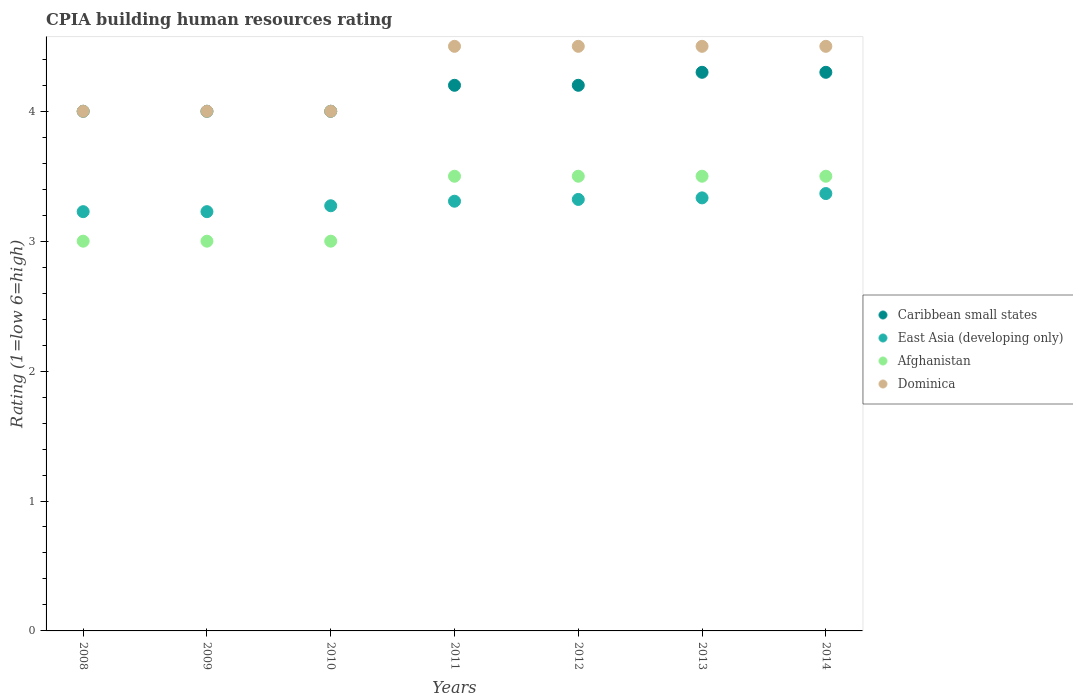Is the number of dotlines equal to the number of legend labels?
Provide a succinct answer. Yes. What is the CPIA rating in Caribbean small states in 2011?
Provide a short and direct response. 4.2. Across all years, what is the maximum CPIA rating in Dominica?
Ensure brevity in your answer.  4.5. Across all years, what is the minimum CPIA rating in Caribbean small states?
Provide a succinct answer. 4. In which year was the CPIA rating in Caribbean small states maximum?
Offer a very short reply. 2013. What is the difference between the CPIA rating in Caribbean small states in 2010 and that in 2012?
Make the answer very short. -0.2. What is the difference between the CPIA rating in Afghanistan in 2010 and the CPIA rating in Dominica in 2009?
Give a very brief answer. -1. What is the average CPIA rating in Caribbean small states per year?
Ensure brevity in your answer.  4.14. In the year 2010, what is the difference between the CPIA rating in Caribbean small states and CPIA rating in East Asia (developing only)?
Your answer should be compact. 0.73. In how many years, is the CPIA rating in Afghanistan greater than 1.8?
Offer a very short reply. 7. What is the ratio of the CPIA rating in East Asia (developing only) in 2008 to that in 2011?
Your answer should be compact. 0.98. Is the CPIA rating in Caribbean small states in 2012 less than that in 2013?
Ensure brevity in your answer.  Yes. Is the difference between the CPIA rating in Caribbean small states in 2010 and 2012 greater than the difference between the CPIA rating in East Asia (developing only) in 2010 and 2012?
Your answer should be compact. No. What is the difference between the highest and the lowest CPIA rating in Caribbean small states?
Provide a short and direct response. 0.3. In how many years, is the CPIA rating in Dominica greater than the average CPIA rating in Dominica taken over all years?
Offer a very short reply. 4. Is the sum of the CPIA rating in Caribbean small states in 2009 and 2010 greater than the maximum CPIA rating in Afghanistan across all years?
Your response must be concise. Yes. Is it the case that in every year, the sum of the CPIA rating in Caribbean small states and CPIA rating in Dominica  is greater than the sum of CPIA rating in Afghanistan and CPIA rating in East Asia (developing only)?
Your answer should be very brief. Yes. Is it the case that in every year, the sum of the CPIA rating in Dominica and CPIA rating in East Asia (developing only)  is greater than the CPIA rating in Caribbean small states?
Give a very brief answer. Yes. Does the CPIA rating in Afghanistan monotonically increase over the years?
Offer a terse response. No. Is the CPIA rating in Caribbean small states strictly less than the CPIA rating in Afghanistan over the years?
Your answer should be compact. No. How many dotlines are there?
Offer a very short reply. 4. Are the values on the major ticks of Y-axis written in scientific E-notation?
Offer a terse response. No. Does the graph contain grids?
Keep it short and to the point. No. Where does the legend appear in the graph?
Provide a succinct answer. Center right. How are the legend labels stacked?
Keep it short and to the point. Vertical. What is the title of the graph?
Ensure brevity in your answer.  CPIA building human resources rating. Does "North America" appear as one of the legend labels in the graph?
Offer a terse response. No. What is the Rating (1=low 6=high) in Caribbean small states in 2008?
Offer a terse response. 4. What is the Rating (1=low 6=high) in East Asia (developing only) in 2008?
Give a very brief answer. 3.23. What is the Rating (1=low 6=high) of Dominica in 2008?
Your answer should be compact. 4. What is the Rating (1=low 6=high) of Caribbean small states in 2009?
Provide a short and direct response. 4. What is the Rating (1=low 6=high) in East Asia (developing only) in 2009?
Provide a short and direct response. 3.23. What is the Rating (1=low 6=high) of Afghanistan in 2009?
Your response must be concise. 3. What is the Rating (1=low 6=high) in East Asia (developing only) in 2010?
Provide a short and direct response. 3.27. What is the Rating (1=low 6=high) of Dominica in 2010?
Your answer should be very brief. 4. What is the Rating (1=low 6=high) of Caribbean small states in 2011?
Ensure brevity in your answer.  4.2. What is the Rating (1=low 6=high) in East Asia (developing only) in 2011?
Your answer should be compact. 3.31. What is the Rating (1=low 6=high) of Afghanistan in 2011?
Keep it short and to the point. 3.5. What is the Rating (1=low 6=high) in Dominica in 2011?
Ensure brevity in your answer.  4.5. What is the Rating (1=low 6=high) in Caribbean small states in 2012?
Your answer should be compact. 4.2. What is the Rating (1=low 6=high) of East Asia (developing only) in 2012?
Keep it short and to the point. 3.32. What is the Rating (1=low 6=high) in Dominica in 2012?
Your answer should be very brief. 4.5. What is the Rating (1=low 6=high) of Caribbean small states in 2013?
Offer a very short reply. 4.3. What is the Rating (1=low 6=high) of East Asia (developing only) in 2013?
Provide a short and direct response. 3.33. What is the Rating (1=low 6=high) in Afghanistan in 2013?
Keep it short and to the point. 3.5. What is the Rating (1=low 6=high) of Caribbean small states in 2014?
Provide a short and direct response. 4.3. What is the Rating (1=low 6=high) in East Asia (developing only) in 2014?
Your answer should be very brief. 3.37. What is the Rating (1=low 6=high) in Afghanistan in 2014?
Your answer should be compact. 3.5. What is the Rating (1=low 6=high) in Dominica in 2014?
Your answer should be very brief. 4.5. Across all years, what is the maximum Rating (1=low 6=high) in Caribbean small states?
Provide a succinct answer. 4.3. Across all years, what is the maximum Rating (1=low 6=high) in East Asia (developing only)?
Offer a very short reply. 3.37. Across all years, what is the minimum Rating (1=low 6=high) of Caribbean small states?
Your response must be concise. 4. Across all years, what is the minimum Rating (1=low 6=high) of East Asia (developing only)?
Make the answer very short. 3.23. Across all years, what is the minimum Rating (1=low 6=high) of Afghanistan?
Your response must be concise. 3. Across all years, what is the minimum Rating (1=low 6=high) of Dominica?
Ensure brevity in your answer.  4. What is the total Rating (1=low 6=high) in East Asia (developing only) in the graph?
Your answer should be compact. 23.06. What is the total Rating (1=low 6=high) in Dominica in the graph?
Ensure brevity in your answer.  30. What is the difference between the Rating (1=low 6=high) in Caribbean small states in 2008 and that in 2009?
Provide a short and direct response. 0. What is the difference between the Rating (1=low 6=high) of East Asia (developing only) in 2008 and that in 2009?
Keep it short and to the point. 0. What is the difference between the Rating (1=low 6=high) in East Asia (developing only) in 2008 and that in 2010?
Offer a very short reply. -0.05. What is the difference between the Rating (1=low 6=high) of Afghanistan in 2008 and that in 2010?
Offer a terse response. 0. What is the difference between the Rating (1=low 6=high) in East Asia (developing only) in 2008 and that in 2011?
Make the answer very short. -0.08. What is the difference between the Rating (1=low 6=high) in Afghanistan in 2008 and that in 2011?
Your response must be concise. -0.5. What is the difference between the Rating (1=low 6=high) of Dominica in 2008 and that in 2011?
Your response must be concise. -0.5. What is the difference between the Rating (1=low 6=high) of Caribbean small states in 2008 and that in 2012?
Your response must be concise. -0.2. What is the difference between the Rating (1=low 6=high) of East Asia (developing only) in 2008 and that in 2012?
Your answer should be very brief. -0.09. What is the difference between the Rating (1=low 6=high) of Dominica in 2008 and that in 2012?
Offer a very short reply. -0.5. What is the difference between the Rating (1=low 6=high) in Caribbean small states in 2008 and that in 2013?
Provide a short and direct response. -0.3. What is the difference between the Rating (1=low 6=high) in East Asia (developing only) in 2008 and that in 2013?
Your answer should be compact. -0.11. What is the difference between the Rating (1=low 6=high) of Afghanistan in 2008 and that in 2013?
Keep it short and to the point. -0.5. What is the difference between the Rating (1=low 6=high) in Dominica in 2008 and that in 2013?
Your answer should be very brief. -0.5. What is the difference between the Rating (1=low 6=high) of Caribbean small states in 2008 and that in 2014?
Provide a short and direct response. -0.3. What is the difference between the Rating (1=low 6=high) in East Asia (developing only) in 2008 and that in 2014?
Ensure brevity in your answer.  -0.14. What is the difference between the Rating (1=low 6=high) in Afghanistan in 2008 and that in 2014?
Provide a succinct answer. -0.5. What is the difference between the Rating (1=low 6=high) of East Asia (developing only) in 2009 and that in 2010?
Give a very brief answer. -0.05. What is the difference between the Rating (1=low 6=high) in Afghanistan in 2009 and that in 2010?
Keep it short and to the point. 0. What is the difference between the Rating (1=low 6=high) of Caribbean small states in 2009 and that in 2011?
Offer a very short reply. -0.2. What is the difference between the Rating (1=low 6=high) of East Asia (developing only) in 2009 and that in 2011?
Your answer should be very brief. -0.08. What is the difference between the Rating (1=low 6=high) of Afghanistan in 2009 and that in 2011?
Ensure brevity in your answer.  -0.5. What is the difference between the Rating (1=low 6=high) of East Asia (developing only) in 2009 and that in 2012?
Offer a very short reply. -0.09. What is the difference between the Rating (1=low 6=high) of East Asia (developing only) in 2009 and that in 2013?
Make the answer very short. -0.11. What is the difference between the Rating (1=low 6=high) in East Asia (developing only) in 2009 and that in 2014?
Your answer should be compact. -0.14. What is the difference between the Rating (1=low 6=high) of East Asia (developing only) in 2010 and that in 2011?
Your answer should be compact. -0.04. What is the difference between the Rating (1=low 6=high) in East Asia (developing only) in 2010 and that in 2012?
Provide a short and direct response. -0.05. What is the difference between the Rating (1=low 6=high) of Afghanistan in 2010 and that in 2012?
Your answer should be very brief. -0.5. What is the difference between the Rating (1=low 6=high) in Dominica in 2010 and that in 2012?
Your answer should be compact. -0.5. What is the difference between the Rating (1=low 6=high) of East Asia (developing only) in 2010 and that in 2013?
Offer a terse response. -0.06. What is the difference between the Rating (1=low 6=high) in Afghanistan in 2010 and that in 2013?
Offer a very short reply. -0.5. What is the difference between the Rating (1=low 6=high) of Dominica in 2010 and that in 2013?
Give a very brief answer. -0.5. What is the difference between the Rating (1=low 6=high) in East Asia (developing only) in 2010 and that in 2014?
Make the answer very short. -0.09. What is the difference between the Rating (1=low 6=high) of Caribbean small states in 2011 and that in 2012?
Provide a short and direct response. 0. What is the difference between the Rating (1=low 6=high) in East Asia (developing only) in 2011 and that in 2012?
Ensure brevity in your answer.  -0.01. What is the difference between the Rating (1=low 6=high) in Dominica in 2011 and that in 2012?
Your answer should be compact. 0. What is the difference between the Rating (1=low 6=high) of Caribbean small states in 2011 and that in 2013?
Keep it short and to the point. -0.1. What is the difference between the Rating (1=low 6=high) in East Asia (developing only) in 2011 and that in 2013?
Make the answer very short. -0.03. What is the difference between the Rating (1=low 6=high) in Afghanistan in 2011 and that in 2013?
Provide a succinct answer. 0. What is the difference between the Rating (1=low 6=high) in Dominica in 2011 and that in 2013?
Offer a terse response. 0. What is the difference between the Rating (1=low 6=high) in Caribbean small states in 2011 and that in 2014?
Your answer should be very brief. -0.1. What is the difference between the Rating (1=low 6=high) of East Asia (developing only) in 2011 and that in 2014?
Make the answer very short. -0.06. What is the difference between the Rating (1=low 6=high) in Afghanistan in 2011 and that in 2014?
Your answer should be compact. 0. What is the difference between the Rating (1=low 6=high) of Caribbean small states in 2012 and that in 2013?
Make the answer very short. -0.1. What is the difference between the Rating (1=low 6=high) of East Asia (developing only) in 2012 and that in 2013?
Offer a terse response. -0.01. What is the difference between the Rating (1=low 6=high) in Dominica in 2012 and that in 2013?
Provide a succinct answer. 0. What is the difference between the Rating (1=low 6=high) in Caribbean small states in 2012 and that in 2014?
Provide a short and direct response. -0.1. What is the difference between the Rating (1=low 6=high) of East Asia (developing only) in 2012 and that in 2014?
Offer a terse response. -0.05. What is the difference between the Rating (1=low 6=high) in Afghanistan in 2012 and that in 2014?
Offer a very short reply. 0. What is the difference between the Rating (1=low 6=high) in Dominica in 2012 and that in 2014?
Keep it short and to the point. 0. What is the difference between the Rating (1=low 6=high) of Caribbean small states in 2013 and that in 2014?
Give a very brief answer. 0. What is the difference between the Rating (1=low 6=high) of East Asia (developing only) in 2013 and that in 2014?
Provide a succinct answer. -0.03. What is the difference between the Rating (1=low 6=high) of Afghanistan in 2013 and that in 2014?
Your response must be concise. 0. What is the difference between the Rating (1=low 6=high) of Caribbean small states in 2008 and the Rating (1=low 6=high) of East Asia (developing only) in 2009?
Keep it short and to the point. 0.77. What is the difference between the Rating (1=low 6=high) in Caribbean small states in 2008 and the Rating (1=low 6=high) in Afghanistan in 2009?
Give a very brief answer. 1. What is the difference between the Rating (1=low 6=high) of Caribbean small states in 2008 and the Rating (1=low 6=high) of Dominica in 2009?
Give a very brief answer. 0. What is the difference between the Rating (1=low 6=high) in East Asia (developing only) in 2008 and the Rating (1=low 6=high) in Afghanistan in 2009?
Your answer should be very brief. 0.23. What is the difference between the Rating (1=low 6=high) of East Asia (developing only) in 2008 and the Rating (1=low 6=high) of Dominica in 2009?
Your response must be concise. -0.77. What is the difference between the Rating (1=low 6=high) in Afghanistan in 2008 and the Rating (1=low 6=high) in Dominica in 2009?
Keep it short and to the point. -1. What is the difference between the Rating (1=low 6=high) in Caribbean small states in 2008 and the Rating (1=low 6=high) in East Asia (developing only) in 2010?
Ensure brevity in your answer.  0.73. What is the difference between the Rating (1=low 6=high) of Caribbean small states in 2008 and the Rating (1=low 6=high) of Afghanistan in 2010?
Provide a succinct answer. 1. What is the difference between the Rating (1=low 6=high) of East Asia (developing only) in 2008 and the Rating (1=low 6=high) of Afghanistan in 2010?
Offer a very short reply. 0.23. What is the difference between the Rating (1=low 6=high) of East Asia (developing only) in 2008 and the Rating (1=low 6=high) of Dominica in 2010?
Your response must be concise. -0.77. What is the difference between the Rating (1=low 6=high) in Caribbean small states in 2008 and the Rating (1=low 6=high) in East Asia (developing only) in 2011?
Your answer should be very brief. 0.69. What is the difference between the Rating (1=low 6=high) of Caribbean small states in 2008 and the Rating (1=low 6=high) of Afghanistan in 2011?
Provide a succinct answer. 0.5. What is the difference between the Rating (1=low 6=high) in East Asia (developing only) in 2008 and the Rating (1=low 6=high) in Afghanistan in 2011?
Your answer should be compact. -0.27. What is the difference between the Rating (1=low 6=high) in East Asia (developing only) in 2008 and the Rating (1=low 6=high) in Dominica in 2011?
Provide a succinct answer. -1.27. What is the difference between the Rating (1=low 6=high) of Afghanistan in 2008 and the Rating (1=low 6=high) of Dominica in 2011?
Your response must be concise. -1.5. What is the difference between the Rating (1=low 6=high) of Caribbean small states in 2008 and the Rating (1=low 6=high) of East Asia (developing only) in 2012?
Provide a short and direct response. 0.68. What is the difference between the Rating (1=low 6=high) in Caribbean small states in 2008 and the Rating (1=low 6=high) in Dominica in 2012?
Provide a short and direct response. -0.5. What is the difference between the Rating (1=low 6=high) in East Asia (developing only) in 2008 and the Rating (1=low 6=high) in Afghanistan in 2012?
Offer a very short reply. -0.27. What is the difference between the Rating (1=low 6=high) of East Asia (developing only) in 2008 and the Rating (1=low 6=high) of Dominica in 2012?
Your answer should be very brief. -1.27. What is the difference between the Rating (1=low 6=high) in Caribbean small states in 2008 and the Rating (1=low 6=high) in Dominica in 2013?
Your response must be concise. -0.5. What is the difference between the Rating (1=low 6=high) of East Asia (developing only) in 2008 and the Rating (1=low 6=high) of Afghanistan in 2013?
Provide a succinct answer. -0.27. What is the difference between the Rating (1=low 6=high) of East Asia (developing only) in 2008 and the Rating (1=low 6=high) of Dominica in 2013?
Keep it short and to the point. -1.27. What is the difference between the Rating (1=low 6=high) in Caribbean small states in 2008 and the Rating (1=low 6=high) in East Asia (developing only) in 2014?
Give a very brief answer. 0.63. What is the difference between the Rating (1=low 6=high) in Caribbean small states in 2008 and the Rating (1=low 6=high) in Afghanistan in 2014?
Keep it short and to the point. 0.5. What is the difference between the Rating (1=low 6=high) of East Asia (developing only) in 2008 and the Rating (1=low 6=high) of Afghanistan in 2014?
Your answer should be compact. -0.27. What is the difference between the Rating (1=low 6=high) of East Asia (developing only) in 2008 and the Rating (1=low 6=high) of Dominica in 2014?
Keep it short and to the point. -1.27. What is the difference between the Rating (1=low 6=high) of Afghanistan in 2008 and the Rating (1=low 6=high) of Dominica in 2014?
Your response must be concise. -1.5. What is the difference between the Rating (1=low 6=high) of Caribbean small states in 2009 and the Rating (1=low 6=high) of East Asia (developing only) in 2010?
Offer a very short reply. 0.73. What is the difference between the Rating (1=low 6=high) in East Asia (developing only) in 2009 and the Rating (1=low 6=high) in Afghanistan in 2010?
Provide a short and direct response. 0.23. What is the difference between the Rating (1=low 6=high) in East Asia (developing only) in 2009 and the Rating (1=low 6=high) in Dominica in 2010?
Your response must be concise. -0.77. What is the difference between the Rating (1=low 6=high) of Caribbean small states in 2009 and the Rating (1=low 6=high) of East Asia (developing only) in 2011?
Ensure brevity in your answer.  0.69. What is the difference between the Rating (1=low 6=high) of Caribbean small states in 2009 and the Rating (1=low 6=high) of Afghanistan in 2011?
Provide a succinct answer. 0.5. What is the difference between the Rating (1=low 6=high) in East Asia (developing only) in 2009 and the Rating (1=low 6=high) in Afghanistan in 2011?
Your answer should be very brief. -0.27. What is the difference between the Rating (1=low 6=high) of East Asia (developing only) in 2009 and the Rating (1=low 6=high) of Dominica in 2011?
Offer a very short reply. -1.27. What is the difference between the Rating (1=low 6=high) of Caribbean small states in 2009 and the Rating (1=low 6=high) of East Asia (developing only) in 2012?
Keep it short and to the point. 0.68. What is the difference between the Rating (1=low 6=high) of East Asia (developing only) in 2009 and the Rating (1=low 6=high) of Afghanistan in 2012?
Provide a short and direct response. -0.27. What is the difference between the Rating (1=low 6=high) in East Asia (developing only) in 2009 and the Rating (1=low 6=high) in Dominica in 2012?
Offer a terse response. -1.27. What is the difference between the Rating (1=low 6=high) of Caribbean small states in 2009 and the Rating (1=low 6=high) of Afghanistan in 2013?
Your answer should be very brief. 0.5. What is the difference between the Rating (1=low 6=high) in Caribbean small states in 2009 and the Rating (1=low 6=high) in Dominica in 2013?
Your answer should be compact. -0.5. What is the difference between the Rating (1=low 6=high) of East Asia (developing only) in 2009 and the Rating (1=low 6=high) of Afghanistan in 2013?
Give a very brief answer. -0.27. What is the difference between the Rating (1=low 6=high) of East Asia (developing only) in 2009 and the Rating (1=low 6=high) of Dominica in 2013?
Your response must be concise. -1.27. What is the difference between the Rating (1=low 6=high) of Afghanistan in 2009 and the Rating (1=low 6=high) of Dominica in 2013?
Make the answer very short. -1.5. What is the difference between the Rating (1=low 6=high) of Caribbean small states in 2009 and the Rating (1=low 6=high) of East Asia (developing only) in 2014?
Ensure brevity in your answer.  0.63. What is the difference between the Rating (1=low 6=high) in Caribbean small states in 2009 and the Rating (1=low 6=high) in Afghanistan in 2014?
Your answer should be very brief. 0.5. What is the difference between the Rating (1=low 6=high) in East Asia (developing only) in 2009 and the Rating (1=low 6=high) in Afghanistan in 2014?
Keep it short and to the point. -0.27. What is the difference between the Rating (1=low 6=high) in East Asia (developing only) in 2009 and the Rating (1=low 6=high) in Dominica in 2014?
Your answer should be very brief. -1.27. What is the difference between the Rating (1=low 6=high) of Caribbean small states in 2010 and the Rating (1=low 6=high) of East Asia (developing only) in 2011?
Give a very brief answer. 0.69. What is the difference between the Rating (1=low 6=high) of Caribbean small states in 2010 and the Rating (1=low 6=high) of Afghanistan in 2011?
Ensure brevity in your answer.  0.5. What is the difference between the Rating (1=low 6=high) in Caribbean small states in 2010 and the Rating (1=low 6=high) in Dominica in 2011?
Your answer should be compact. -0.5. What is the difference between the Rating (1=low 6=high) in East Asia (developing only) in 2010 and the Rating (1=low 6=high) in Afghanistan in 2011?
Your response must be concise. -0.23. What is the difference between the Rating (1=low 6=high) of East Asia (developing only) in 2010 and the Rating (1=low 6=high) of Dominica in 2011?
Your response must be concise. -1.23. What is the difference between the Rating (1=low 6=high) in Caribbean small states in 2010 and the Rating (1=low 6=high) in East Asia (developing only) in 2012?
Ensure brevity in your answer.  0.68. What is the difference between the Rating (1=low 6=high) of Caribbean small states in 2010 and the Rating (1=low 6=high) of Dominica in 2012?
Offer a terse response. -0.5. What is the difference between the Rating (1=low 6=high) of East Asia (developing only) in 2010 and the Rating (1=low 6=high) of Afghanistan in 2012?
Your answer should be very brief. -0.23. What is the difference between the Rating (1=low 6=high) in East Asia (developing only) in 2010 and the Rating (1=low 6=high) in Dominica in 2012?
Offer a very short reply. -1.23. What is the difference between the Rating (1=low 6=high) in Afghanistan in 2010 and the Rating (1=low 6=high) in Dominica in 2012?
Your response must be concise. -1.5. What is the difference between the Rating (1=low 6=high) in Caribbean small states in 2010 and the Rating (1=low 6=high) in East Asia (developing only) in 2013?
Keep it short and to the point. 0.67. What is the difference between the Rating (1=low 6=high) in Caribbean small states in 2010 and the Rating (1=low 6=high) in Dominica in 2013?
Ensure brevity in your answer.  -0.5. What is the difference between the Rating (1=low 6=high) of East Asia (developing only) in 2010 and the Rating (1=low 6=high) of Afghanistan in 2013?
Your response must be concise. -0.23. What is the difference between the Rating (1=low 6=high) in East Asia (developing only) in 2010 and the Rating (1=low 6=high) in Dominica in 2013?
Ensure brevity in your answer.  -1.23. What is the difference between the Rating (1=low 6=high) of Caribbean small states in 2010 and the Rating (1=low 6=high) of East Asia (developing only) in 2014?
Give a very brief answer. 0.63. What is the difference between the Rating (1=low 6=high) of East Asia (developing only) in 2010 and the Rating (1=low 6=high) of Afghanistan in 2014?
Keep it short and to the point. -0.23. What is the difference between the Rating (1=low 6=high) of East Asia (developing only) in 2010 and the Rating (1=low 6=high) of Dominica in 2014?
Keep it short and to the point. -1.23. What is the difference between the Rating (1=low 6=high) of Afghanistan in 2010 and the Rating (1=low 6=high) of Dominica in 2014?
Provide a succinct answer. -1.5. What is the difference between the Rating (1=low 6=high) in Caribbean small states in 2011 and the Rating (1=low 6=high) in East Asia (developing only) in 2012?
Ensure brevity in your answer.  0.88. What is the difference between the Rating (1=low 6=high) in Caribbean small states in 2011 and the Rating (1=low 6=high) in Afghanistan in 2012?
Your response must be concise. 0.7. What is the difference between the Rating (1=low 6=high) of East Asia (developing only) in 2011 and the Rating (1=low 6=high) of Afghanistan in 2012?
Your answer should be very brief. -0.19. What is the difference between the Rating (1=low 6=high) of East Asia (developing only) in 2011 and the Rating (1=low 6=high) of Dominica in 2012?
Provide a short and direct response. -1.19. What is the difference between the Rating (1=low 6=high) of Afghanistan in 2011 and the Rating (1=low 6=high) of Dominica in 2012?
Your response must be concise. -1. What is the difference between the Rating (1=low 6=high) of Caribbean small states in 2011 and the Rating (1=low 6=high) of East Asia (developing only) in 2013?
Provide a succinct answer. 0.87. What is the difference between the Rating (1=low 6=high) of Caribbean small states in 2011 and the Rating (1=low 6=high) of Afghanistan in 2013?
Provide a succinct answer. 0.7. What is the difference between the Rating (1=low 6=high) in Caribbean small states in 2011 and the Rating (1=low 6=high) in Dominica in 2013?
Offer a very short reply. -0.3. What is the difference between the Rating (1=low 6=high) in East Asia (developing only) in 2011 and the Rating (1=low 6=high) in Afghanistan in 2013?
Give a very brief answer. -0.19. What is the difference between the Rating (1=low 6=high) of East Asia (developing only) in 2011 and the Rating (1=low 6=high) of Dominica in 2013?
Ensure brevity in your answer.  -1.19. What is the difference between the Rating (1=low 6=high) in Caribbean small states in 2011 and the Rating (1=low 6=high) in East Asia (developing only) in 2014?
Your answer should be compact. 0.83. What is the difference between the Rating (1=low 6=high) of East Asia (developing only) in 2011 and the Rating (1=low 6=high) of Afghanistan in 2014?
Provide a short and direct response. -0.19. What is the difference between the Rating (1=low 6=high) in East Asia (developing only) in 2011 and the Rating (1=low 6=high) in Dominica in 2014?
Offer a terse response. -1.19. What is the difference between the Rating (1=low 6=high) of Caribbean small states in 2012 and the Rating (1=low 6=high) of East Asia (developing only) in 2013?
Give a very brief answer. 0.87. What is the difference between the Rating (1=low 6=high) of East Asia (developing only) in 2012 and the Rating (1=low 6=high) of Afghanistan in 2013?
Provide a short and direct response. -0.18. What is the difference between the Rating (1=low 6=high) of East Asia (developing only) in 2012 and the Rating (1=low 6=high) of Dominica in 2013?
Keep it short and to the point. -1.18. What is the difference between the Rating (1=low 6=high) in East Asia (developing only) in 2012 and the Rating (1=low 6=high) in Afghanistan in 2014?
Give a very brief answer. -0.18. What is the difference between the Rating (1=low 6=high) in East Asia (developing only) in 2012 and the Rating (1=low 6=high) in Dominica in 2014?
Your answer should be very brief. -1.18. What is the difference between the Rating (1=low 6=high) in Caribbean small states in 2013 and the Rating (1=low 6=high) in Afghanistan in 2014?
Keep it short and to the point. 0.8. What is the difference between the Rating (1=low 6=high) of East Asia (developing only) in 2013 and the Rating (1=low 6=high) of Dominica in 2014?
Keep it short and to the point. -1.17. What is the difference between the Rating (1=low 6=high) in Afghanistan in 2013 and the Rating (1=low 6=high) in Dominica in 2014?
Make the answer very short. -1. What is the average Rating (1=low 6=high) of Caribbean small states per year?
Your answer should be compact. 4.14. What is the average Rating (1=low 6=high) of East Asia (developing only) per year?
Offer a terse response. 3.29. What is the average Rating (1=low 6=high) of Afghanistan per year?
Your answer should be compact. 3.29. What is the average Rating (1=low 6=high) of Dominica per year?
Your answer should be very brief. 4.29. In the year 2008, what is the difference between the Rating (1=low 6=high) of Caribbean small states and Rating (1=low 6=high) of East Asia (developing only)?
Give a very brief answer. 0.77. In the year 2008, what is the difference between the Rating (1=low 6=high) in Caribbean small states and Rating (1=low 6=high) in Afghanistan?
Keep it short and to the point. 1. In the year 2008, what is the difference between the Rating (1=low 6=high) in Caribbean small states and Rating (1=low 6=high) in Dominica?
Provide a short and direct response. 0. In the year 2008, what is the difference between the Rating (1=low 6=high) of East Asia (developing only) and Rating (1=low 6=high) of Afghanistan?
Keep it short and to the point. 0.23. In the year 2008, what is the difference between the Rating (1=low 6=high) of East Asia (developing only) and Rating (1=low 6=high) of Dominica?
Give a very brief answer. -0.77. In the year 2008, what is the difference between the Rating (1=low 6=high) in Afghanistan and Rating (1=low 6=high) in Dominica?
Your response must be concise. -1. In the year 2009, what is the difference between the Rating (1=low 6=high) in Caribbean small states and Rating (1=low 6=high) in East Asia (developing only)?
Your answer should be very brief. 0.77. In the year 2009, what is the difference between the Rating (1=low 6=high) of Caribbean small states and Rating (1=low 6=high) of Dominica?
Provide a short and direct response. 0. In the year 2009, what is the difference between the Rating (1=low 6=high) in East Asia (developing only) and Rating (1=low 6=high) in Afghanistan?
Give a very brief answer. 0.23. In the year 2009, what is the difference between the Rating (1=low 6=high) of East Asia (developing only) and Rating (1=low 6=high) of Dominica?
Your response must be concise. -0.77. In the year 2009, what is the difference between the Rating (1=low 6=high) of Afghanistan and Rating (1=low 6=high) of Dominica?
Make the answer very short. -1. In the year 2010, what is the difference between the Rating (1=low 6=high) of Caribbean small states and Rating (1=low 6=high) of East Asia (developing only)?
Make the answer very short. 0.73. In the year 2010, what is the difference between the Rating (1=low 6=high) in Caribbean small states and Rating (1=low 6=high) in Afghanistan?
Offer a terse response. 1. In the year 2010, what is the difference between the Rating (1=low 6=high) in East Asia (developing only) and Rating (1=low 6=high) in Afghanistan?
Keep it short and to the point. 0.27. In the year 2010, what is the difference between the Rating (1=low 6=high) in East Asia (developing only) and Rating (1=low 6=high) in Dominica?
Ensure brevity in your answer.  -0.73. In the year 2011, what is the difference between the Rating (1=low 6=high) in Caribbean small states and Rating (1=low 6=high) in East Asia (developing only)?
Offer a terse response. 0.89. In the year 2011, what is the difference between the Rating (1=low 6=high) of Caribbean small states and Rating (1=low 6=high) of Dominica?
Make the answer very short. -0.3. In the year 2011, what is the difference between the Rating (1=low 6=high) in East Asia (developing only) and Rating (1=low 6=high) in Afghanistan?
Your response must be concise. -0.19. In the year 2011, what is the difference between the Rating (1=low 6=high) in East Asia (developing only) and Rating (1=low 6=high) in Dominica?
Make the answer very short. -1.19. In the year 2012, what is the difference between the Rating (1=low 6=high) of Caribbean small states and Rating (1=low 6=high) of East Asia (developing only)?
Give a very brief answer. 0.88. In the year 2012, what is the difference between the Rating (1=low 6=high) of East Asia (developing only) and Rating (1=low 6=high) of Afghanistan?
Your answer should be compact. -0.18. In the year 2012, what is the difference between the Rating (1=low 6=high) in East Asia (developing only) and Rating (1=low 6=high) in Dominica?
Your response must be concise. -1.18. In the year 2013, what is the difference between the Rating (1=low 6=high) of Caribbean small states and Rating (1=low 6=high) of East Asia (developing only)?
Your answer should be compact. 0.97. In the year 2013, what is the difference between the Rating (1=low 6=high) in Caribbean small states and Rating (1=low 6=high) in Dominica?
Keep it short and to the point. -0.2. In the year 2013, what is the difference between the Rating (1=low 6=high) of East Asia (developing only) and Rating (1=low 6=high) of Afghanistan?
Keep it short and to the point. -0.17. In the year 2013, what is the difference between the Rating (1=low 6=high) in East Asia (developing only) and Rating (1=low 6=high) in Dominica?
Offer a terse response. -1.17. In the year 2014, what is the difference between the Rating (1=low 6=high) of Caribbean small states and Rating (1=low 6=high) of East Asia (developing only)?
Make the answer very short. 0.93. In the year 2014, what is the difference between the Rating (1=low 6=high) of Caribbean small states and Rating (1=low 6=high) of Dominica?
Your answer should be very brief. -0.2. In the year 2014, what is the difference between the Rating (1=low 6=high) in East Asia (developing only) and Rating (1=low 6=high) in Afghanistan?
Ensure brevity in your answer.  -0.13. In the year 2014, what is the difference between the Rating (1=low 6=high) in East Asia (developing only) and Rating (1=low 6=high) in Dominica?
Give a very brief answer. -1.13. What is the ratio of the Rating (1=low 6=high) in Caribbean small states in 2008 to that in 2010?
Provide a short and direct response. 1. What is the ratio of the Rating (1=low 6=high) in East Asia (developing only) in 2008 to that in 2010?
Your response must be concise. 0.99. What is the ratio of the Rating (1=low 6=high) of Caribbean small states in 2008 to that in 2011?
Your answer should be compact. 0.95. What is the ratio of the Rating (1=low 6=high) in East Asia (developing only) in 2008 to that in 2011?
Provide a succinct answer. 0.98. What is the ratio of the Rating (1=low 6=high) of Afghanistan in 2008 to that in 2011?
Your answer should be very brief. 0.86. What is the ratio of the Rating (1=low 6=high) of East Asia (developing only) in 2008 to that in 2012?
Keep it short and to the point. 0.97. What is the ratio of the Rating (1=low 6=high) in Afghanistan in 2008 to that in 2012?
Ensure brevity in your answer.  0.86. What is the ratio of the Rating (1=low 6=high) in Caribbean small states in 2008 to that in 2013?
Provide a short and direct response. 0.93. What is the ratio of the Rating (1=low 6=high) in East Asia (developing only) in 2008 to that in 2013?
Your answer should be compact. 0.97. What is the ratio of the Rating (1=low 6=high) in Afghanistan in 2008 to that in 2013?
Your answer should be compact. 0.86. What is the ratio of the Rating (1=low 6=high) in Dominica in 2008 to that in 2013?
Offer a very short reply. 0.89. What is the ratio of the Rating (1=low 6=high) in Caribbean small states in 2008 to that in 2014?
Keep it short and to the point. 0.93. What is the ratio of the Rating (1=low 6=high) in East Asia (developing only) in 2008 to that in 2014?
Offer a terse response. 0.96. What is the ratio of the Rating (1=low 6=high) of Afghanistan in 2008 to that in 2014?
Offer a very short reply. 0.86. What is the ratio of the Rating (1=low 6=high) of Caribbean small states in 2009 to that in 2010?
Offer a very short reply. 1. What is the ratio of the Rating (1=low 6=high) of East Asia (developing only) in 2009 to that in 2010?
Provide a succinct answer. 0.99. What is the ratio of the Rating (1=low 6=high) in Dominica in 2009 to that in 2010?
Make the answer very short. 1. What is the ratio of the Rating (1=low 6=high) of Caribbean small states in 2009 to that in 2011?
Make the answer very short. 0.95. What is the ratio of the Rating (1=low 6=high) of East Asia (developing only) in 2009 to that in 2011?
Make the answer very short. 0.98. What is the ratio of the Rating (1=low 6=high) of Caribbean small states in 2009 to that in 2012?
Keep it short and to the point. 0.95. What is the ratio of the Rating (1=low 6=high) of East Asia (developing only) in 2009 to that in 2012?
Offer a terse response. 0.97. What is the ratio of the Rating (1=low 6=high) in Dominica in 2009 to that in 2012?
Give a very brief answer. 0.89. What is the ratio of the Rating (1=low 6=high) in Caribbean small states in 2009 to that in 2013?
Offer a terse response. 0.93. What is the ratio of the Rating (1=low 6=high) of East Asia (developing only) in 2009 to that in 2013?
Ensure brevity in your answer.  0.97. What is the ratio of the Rating (1=low 6=high) in Caribbean small states in 2009 to that in 2014?
Offer a very short reply. 0.93. What is the ratio of the Rating (1=low 6=high) in East Asia (developing only) in 2009 to that in 2014?
Make the answer very short. 0.96. What is the ratio of the Rating (1=low 6=high) of Caribbean small states in 2010 to that in 2011?
Give a very brief answer. 0.95. What is the ratio of the Rating (1=low 6=high) of East Asia (developing only) in 2010 to that in 2011?
Your answer should be very brief. 0.99. What is the ratio of the Rating (1=low 6=high) of Afghanistan in 2010 to that in 2012?
Provide a short and direct response. 0.86. What is the ratio of the Rating (1=low 6=high) in Caribbean small states in 2010 to that in 2013?
Provide a short and direct response. 0.93. What is the ratio of the Rating (1=low 6=high) in East Asia (developing only) in 2010 to that in 2013?
Give a very brief answer. 0.98. What is the ratio of the Rating (1=low 6=high) of Afghanistan in 2010 to that in 2013?
Provide a succinct answer. 0.86. What is the ratio of the Rating (1=low 6=high) in Dominica in 2010 to that in 2013?
Offer a very short reply. 0.89. What is the ratio of the Rating (1=low 6=high) in Caribbean small states in 2010 to that in 2014?
Your response must be concise. 0.93. What is the ratio of the Rating (1=low 6=high) of East Asia (developing only) in 2010 to that in 2014?
Provide a short and direct response. 0.97. What is the ratio of the Rating (1=low 6=high) of Caribbean small states in 2011 to that in 2012?
Ensure brevity in your answer.  1. What is the ratio of the Rating (1=low 6=high) of East Asia (developing only) in 2011 to that in 2012?
Give a very brief answer. 1. What is the ratio of the Rating (1=low 6=high) in Caribbean small states in 2011 to that in 2013?
Provide a short and direct response. 0.98. What is the ratio of the Rating (1=low 6=high) in East Asia (developing only) in 2011 to that in 2013?
Provide a succinct answer. 0.99. What is the ratio of the Rating (1=low 6=high) in Caribbean small states in 2011 to that in 2014?
Keep it short and to the point. 0.98. What is the ratio of the Rating (1=low 6=high) in East Asia (developing only) in 2011 to that in 2014?
Your answer should be very brief. 0.98. What is the ratio of the Rating (1=low 6=high) in Dominica in 2011 to that in 2014?
Your answer should be compact. 1. What is the ratio of the Rating (1=low 6=high) in Caribbean small states in 2012 to that in 2013?
Ensure brevity in your answer.  0.98. What is the ratio of the Rating (1=low 6=high) of Afghanistan in 2012 to that in 2013?
Provide a short and direct response. 1. What is the ratio of the Rating (1=low 6=high) of Caribbean small states in 2012 to that in 2014?
Provide a short and direct response. 0.98. What is the ratio of the Rating (1=low 6=high) in East Asia (developing only) in 2012 to that in 2014?
Your answer should be compact. 0.99. What is the ratio of the Rating (1=low 6=high) of Afghanistan in 2012 to that in 2014?
Give a very brief answer. 1. What is the ratio of the Rating (1=low 6=high) in Afghanistan in 2013 to that in 2014?
Keep it short and to the point. 1. What is the difference between the highest and the second highest Rating (1=low 6=high) in Caribbean small states?
Offer a terse response. 0. What is the difference between the highest and the second highest Rating (1=low 6=high) in East Asia (developing only)?
Offer a terse response. 0.03. What is the difference between the highest and the second highest Rating (1=low 6=high) of Afghanistan?
Your answer should be compact. 0. What is the difference between the highest and the lowest Rating (1=low 6=high) of Caribbean small states?
Give a very brief answer. 0.3. What is the difference between the highest and the lowest Rating (1=low 6=high) of East Asia (developing only)?
Your response must be concise. 0.14. What is the difference between the highest and the lowest Rating (1=low 6=high) of Afghanistan?
Your answer should be very brief. 0.5. What is the difference between the highest and the lowest Rating (1=low 6=high) of Dominica?
Your answer should be compact. 0.5. 